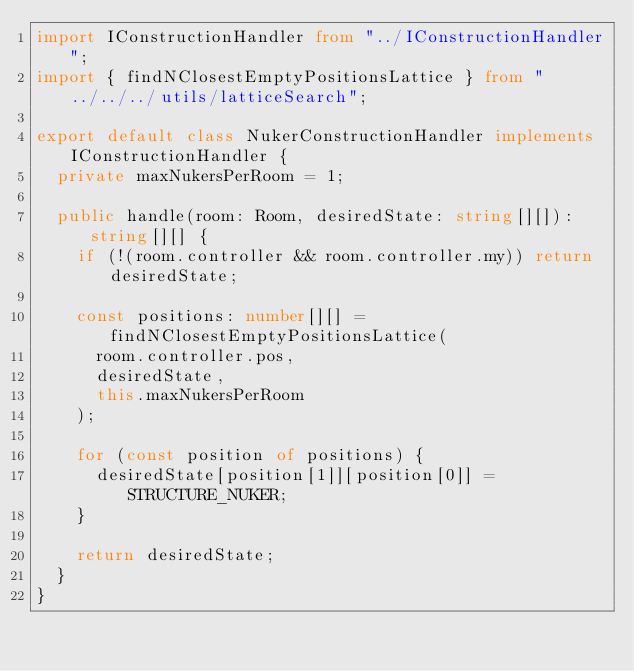Convert code to text. <code><loc_0><loc_0><loc_500><loc_500><_TypeScript_>import IConstructionHandler from "../IConstructionHandler";
import { findNClosestEmptyPositionsLattice } from "../../../utils/latticeSearch";

export default class NukerConstructionHandler implements IConstructionHandler {
  private maxNukersPerRoom = 1;

  public handle(room: Room, desiredState: string[][]): string[][] {
    if (!(room.controller && room.controller.my)) return desiredState;

    const positions: number[][] = findNClosestEmptyPositionsLattice(
      room.controller.pos,
      desiredState,
      this.maxNukersPerRoom
    );

    for (const position of positions) {
      desiredState[position[1]][position[0]] = STRUCTURE_NUKER;
    }

    return desiredState;
  }
}
</code> 